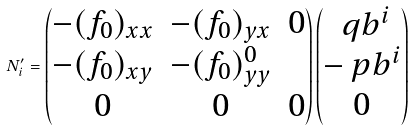<formula> <loc_0><loc_0><loc_500><loc_500>N ^ { \prime } _ { i } = \begin{pmatrix} - ( f _ { 0 } ) _ { x x } & - ( f _ { 0 } ) _ { y x } & 0 \\ - ( f _ { 0 } ) _ { x y } & - ( f _ { 0 } ) _ { y y } ^ { 0 } \\ 0 & 0 & 0 \end{pmatrix} \begin{pmatrix} \ q b ^ { i } \\ - \ p b ^ { i } \\ 0 \end{pmatrix}</formula> 